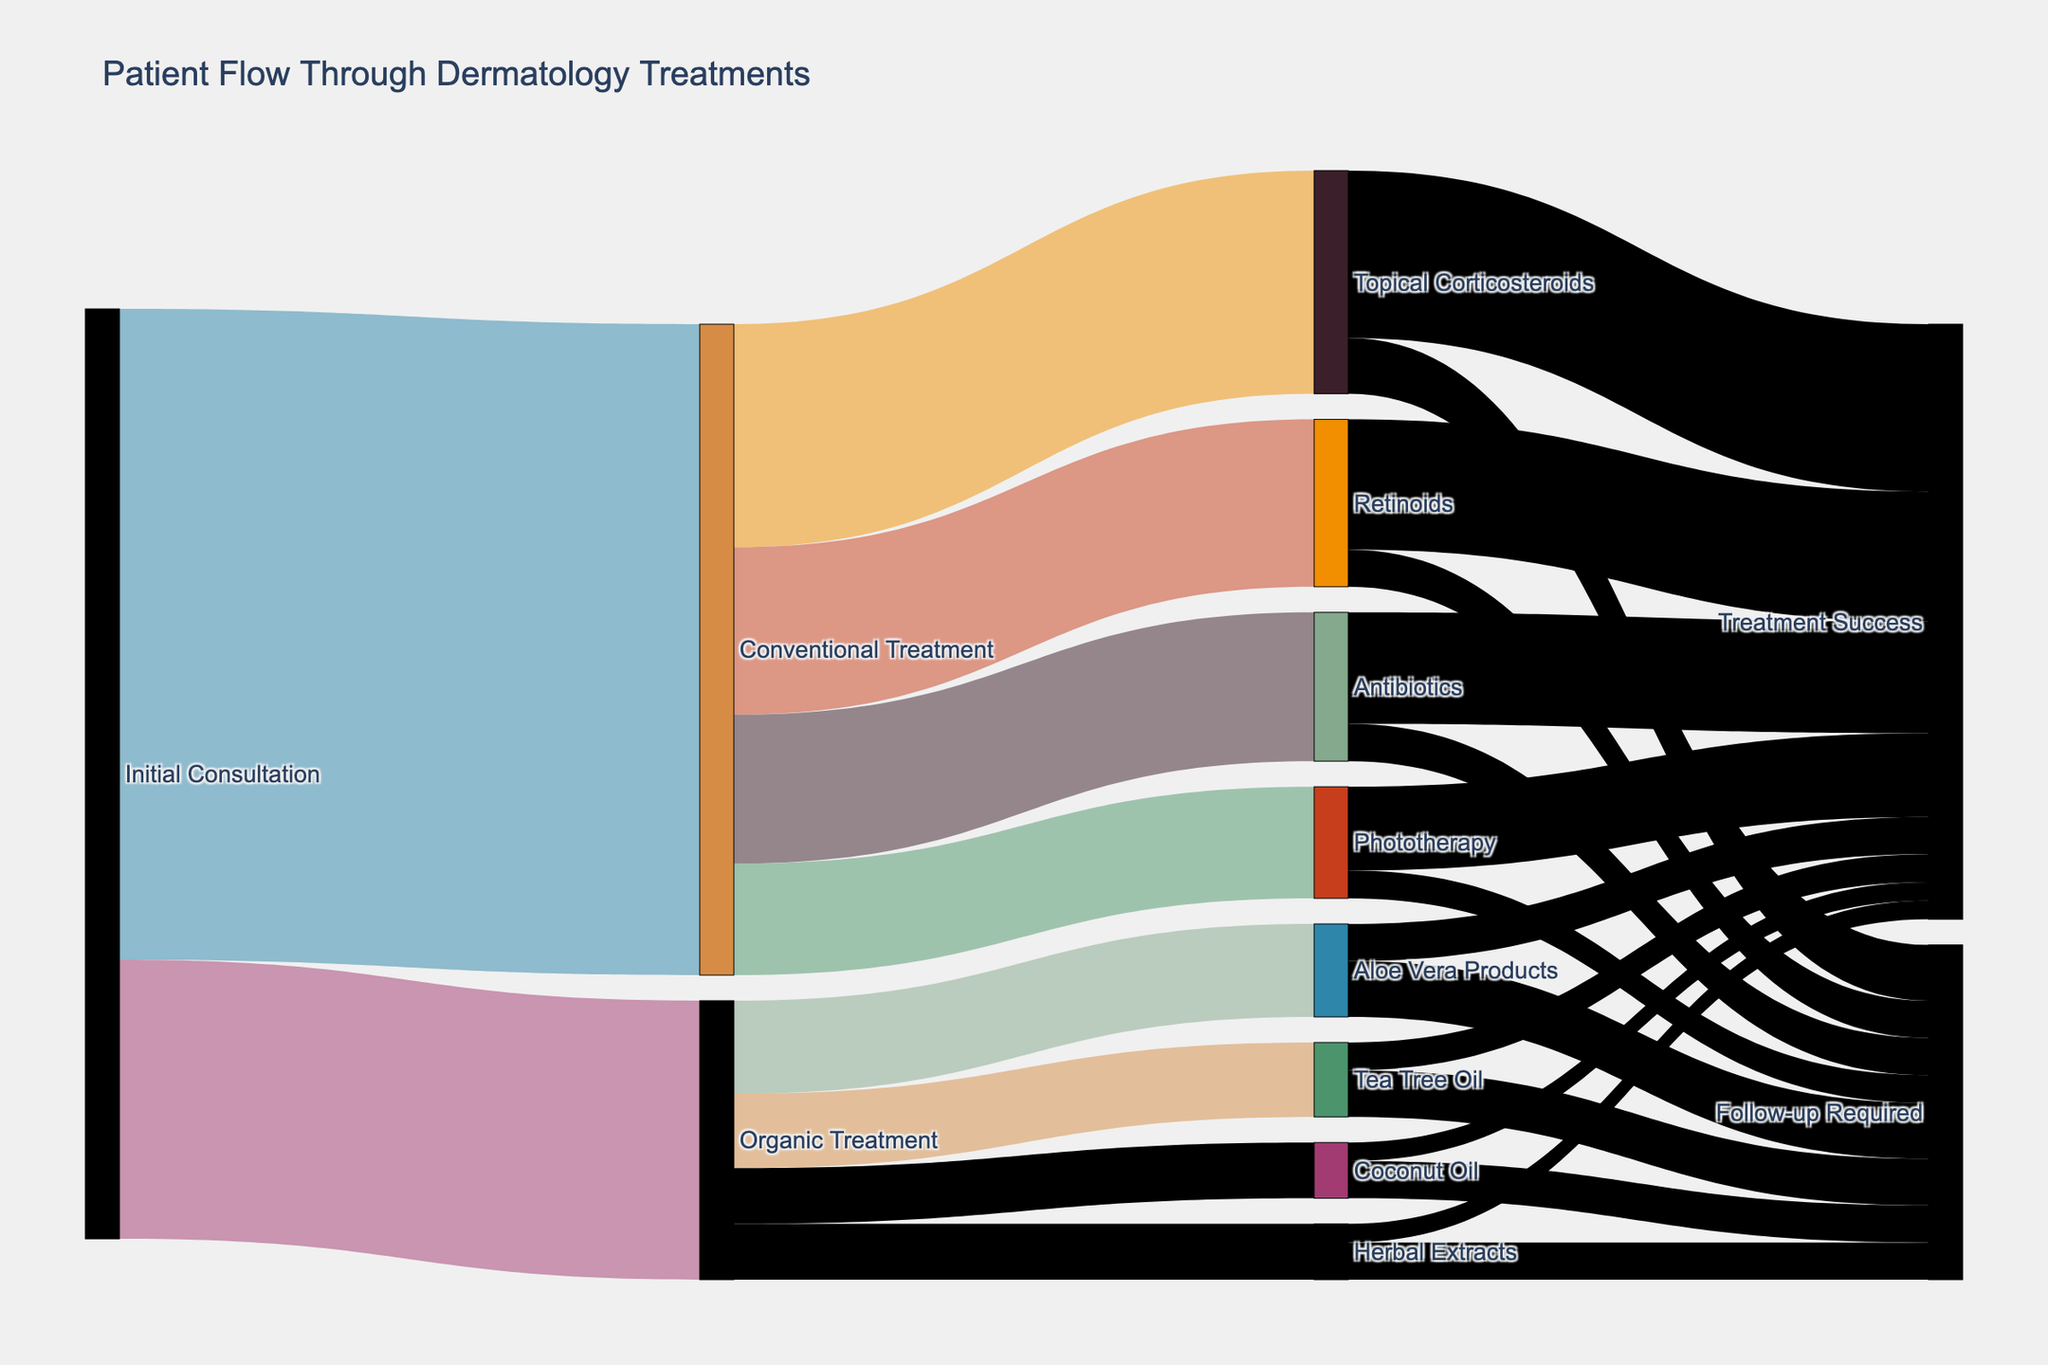What is the total number of initial consultations? The figure shows two paths from "Initial Consultation": one leading to "Conventional Treatment" (350) and another to "Organic Treatment" (150). Therefore, the total is 350 + 150.
Answer: 500 What treatment has the highest number of patients? Among the treatments following the "Initial Consultation", "Conventional Treatment" has 350 patients, which is higher than the 150 for "Organic Treatment".
Answer: Conventional Treatment How many patients achieved treatment success from Conventional Treatments? Sum the patients who achieved treatment success via "Topical Corticosteroids" (90), "Retinoids" (70), "Antibiotics" (60), and "Phototherapy" (45).
Answer: 265 What proportion of patients using Organic Treatments required follow-ups? Sum the follow-up values for "Aloe Vera Products" (30), "Tea Tree Oil" (25), "Coconut Oil" (20), and "Herbal Extracts" (20), then divide by the total initial consultations for "Organic Treatment" (150).
Answer: 0.633 Which Organic Treatment has the lowest number of patients achieving treatment success? Compare the values under the "Organic Treatment" category: "Aloe Vera Products" (20), "Tea Tree Oil" (15), "Coconut Oil" (10), and "Herbal Extracts" (10).
Answer: Coconut Oil and Herbal Extracts How many more patients followed up after Organic Treatments compared to Conventional Treatments? Sum "Follow-up Required" for Organic Treatments (30+25+20+20) and Conventional Treatments (30+20+20+15), then compute the difference.
Answer: 10 What is the relative success rate of Retinoids compared to Topical Corticosteroids? For each: Success patients divided by initial treatment patients. Retinoids: 70/90 and Topical Corticosteroids: 90/120. Compare the success rates.
Answer: Retinoids: 0.778; Topical Corticosteroids: 0.75 Based on the diagram, which group has a higher success rate, Organic or Conventional Treatments? Calculate the success rate separately. Organic: (Sum of success)/(Sum of initial consultations), i.e., (20+15+10+10)/(50+40+30+30). Conventional is calculated similarly. Compare the success rates.
Answer: Conventional Treatments 